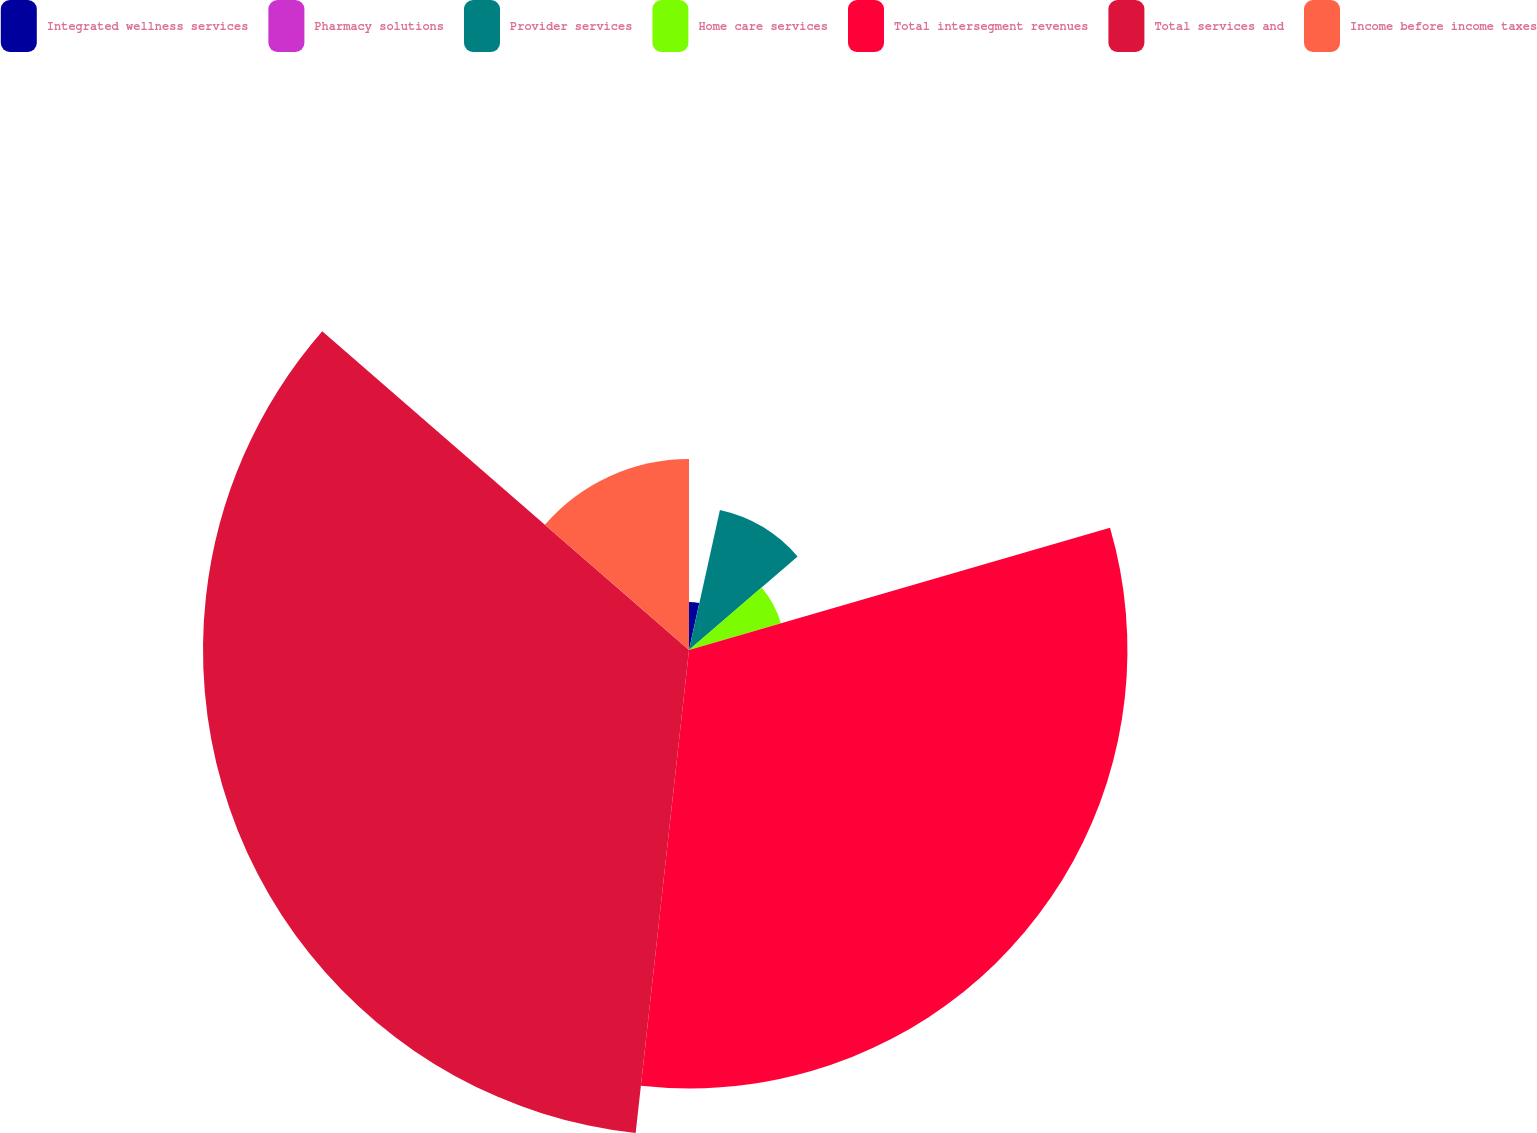<chart> <loc_0><loc_0><loc_500><loc_500><pie_chart><fcel>Integrated wellness services<fcel>Pharmacy solutions<fcel>Provider services<fcel>Home care services<fcel>Total intersegment revenues<fcel>Total services and<fcel>Income before income taxes<nl><fcel>3.43%<fcel>0.03%<fcel>10.22%<fcel>6.82%<fcel>31.25%<fcel>34.64%<fcel>13.61%<nl></chart> 